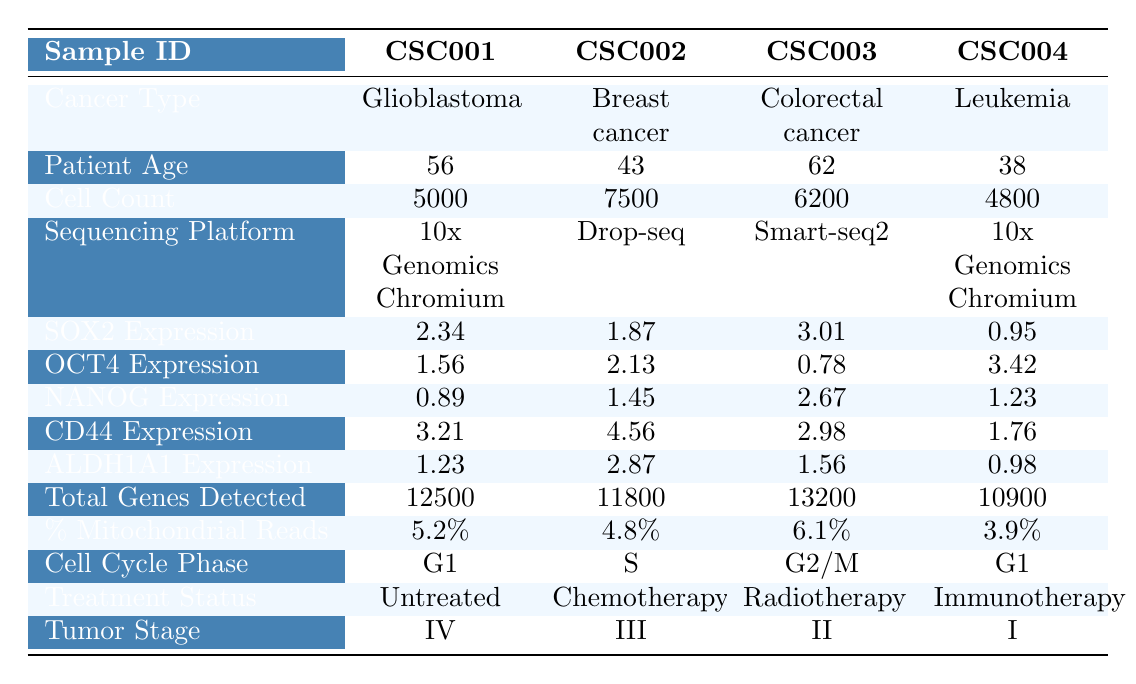What is the cancer type for sample CSC003? The table shows that the cancer type corresponding to sample CSC003 is Colorectal cancer.
Answer: Colorectal cancer What is the patient age for the sample with the highest SOX2 expression? Sample CSC003 has the highest SOX2 expression at 3.01, and the patient age for this sample is 62.
Answer: 62 Which treatment status is associated with the sample from a patient aged 38? For the sample with patient age 38, which is CSC004, the treatment status is Immunotherapy.
Answer: Immunotherapy What is the total gene count for sample CSC002? The table indicates that the total genes detected for sample CSC002 is 11800.
Answer: 11800 Is the percent mitochondrial reads highest for CSC001? By comparing the percent mitochondrial reads, CSC001 has 5.2%, which is not the highest; CSC003 has the highest at 6.1%.
Answer: No What is the average patient age across all samples? The sum of the ages is (56 + 43 + 62 + 38 + 71) = 270, and there are 5 samples. Thus, the average age is 270 / 5 = 54.
Answer: 54 For which sample is CD44 expression highest, and what is that value? The highest CD44 expression is in sample CSC002, with a value of 4.56.
Answer: 4.56 Which sequencing platform is used for sample CSC005? The table shows that the sequencing platform for sample CSC005 is inDrop.
Answer: inDrop What is the difference in ALDH1A1 expression between CSC002 and CSC004? The ALDH1A1 expression for CSC002 is 2.87 and for CSC004 is 0.98. The difference is 2.87 - 0.98 = 1.89.
Answer: 1.89 How many samples have a tumor stage of III or higher? The samples with tumor stages of III or higher are CSC001, CSC002, and CSC005, totaling 3 samples.
Answer: 3 What type of cancer is associated with the sample that has the lowest oct4 expression? The lowest oct4 expression is in sample CSC003 at 0.78, which is associated with Colorectal cancer.
Answer: Colorectal cancer What percentage of the samples are treated with radiotherapy? There are 5 samples in total, and only 1 sample (CSC003) is treated with radiotherapy, which is 1 out of 5, equating to 20%.
Answer: 20% 